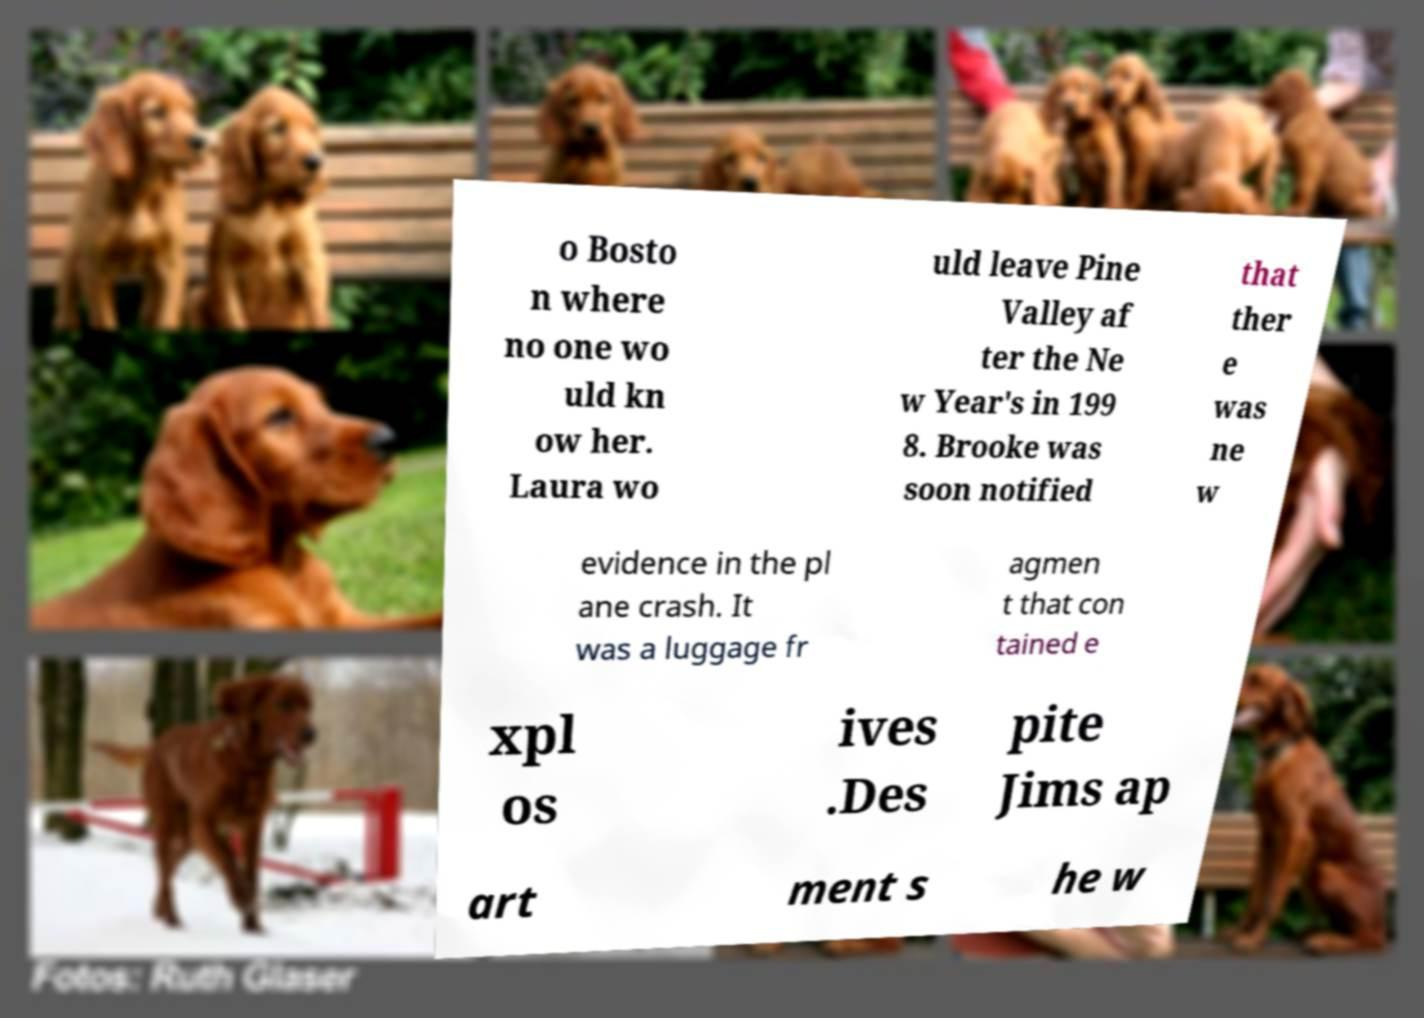For documentation purposes, I need the text within this image transcribed. Could you provide that? o Bosto n where no one wo uld kn ow her. Laura wo uld leave Pine Valley af ter the Ne w Year's in 199 8. Brooke was soon notified that ther e was ne w evidence in the pl ane crash. It was a luggage fr agmen t that con tained e xpl os ives .Des pite Jims ap art ment s he w 